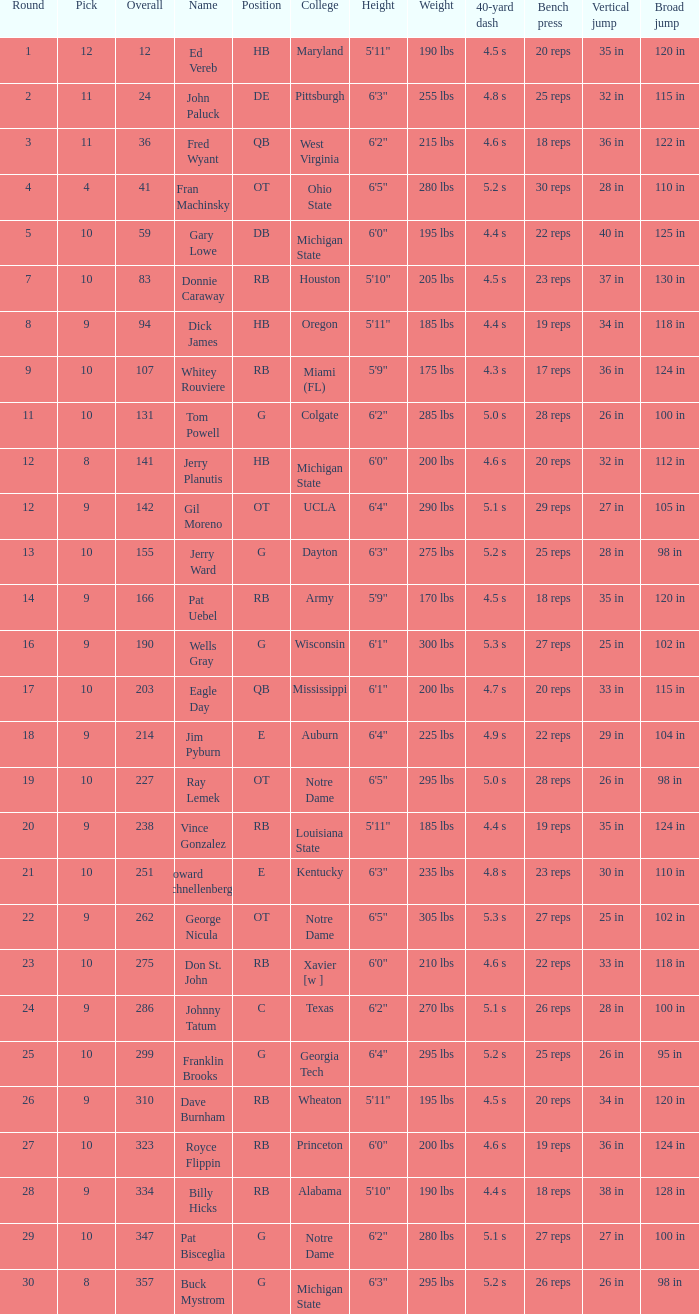What is the overall pick number for a draft pick smaller than 9, named buck mystrom from Michigan State college? 357.0. 